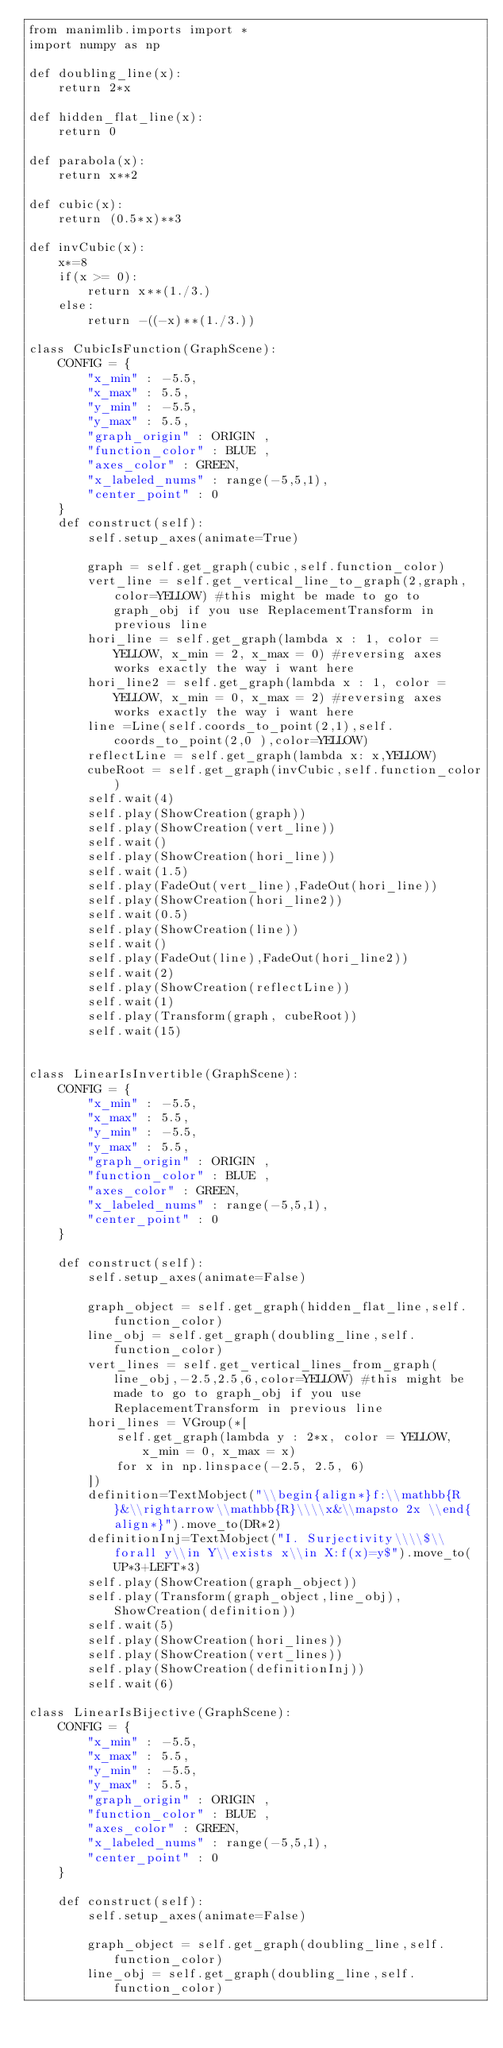<code> <loc_0><loc_0><loc_500><loc_500><_Python_>from manimlib.imports import *
import numpy as np

def doubling_line(x):
    return 2*x

def hidden_flat_line(x):
    return 0

def parabola(x):
    return x**2

def cubic(x):
    return (0.5*x)**3

def invCubic(x):
    x*=8
    if(x >= 0):
        return x**(1./3.)
    else:
        return -((-x)**(1./3.))

class CubicIsFunction(GraphScene):
    CONFIG = {
        "x_min" : -5.5,
        "x_max" : 5.5,
        "y_min" : -5.5,
        "y_max" : 5.5,
        "graph_origin" : ORIGIN ,
        "function_color" : BLUE ,
        "axes_color" : GREEN,
        "x_labeled_nums" : range(-5,5,1),
        "center_point" : 0
    }  
    def construct(self):
        self.setup_axes(animate=True)
        
        graph = self.get_graph(cubic,self.function_color)
        vert_line = self.get_vertical_line_to_graph(2,graph,color=YELLOW) #this might be made to go to graph_obj if you use ReplacementTransform in previous line
        hori_line = self.get_graph(lambda x : 1, color = YELLOW, x_min = 2, x_max = 0) #reversing axes works exactly the way i want here
        hori_line2 = self.get_graph(lambda x : 1, color = YELLOW, x_min = 0, x_max = 2) #reversing axes works exactly the way i want here
        line =Line(self.coords_to_point(2,1),self.coords_to_point(2,0 ),color=YELLOW)
        reflectLine = self.get_graph(lambda x: x,YELLOW)
        cubeRoot = self.get_graph(invCubic,self.function_color)
        self.wait(4)
        self.play(ShowCreation(graph))
        self.play(ShowCreation(vert_line))
        self.wait()
        self.play(ShowCreation(hori_line))
        self.wait(1.5)
        self.play(FadeOut(vert_line),FadeOut(hori_line))
        self.play(ShowCreation(hori_line2))
        self.wait(0.5)
        self.play(ShowCreation(line))
        self.wait()
        self.play(FadeOut(line),FadeOut(hori_line2))
        self.wait(2)
        self.play(ShowCreation(reflectLine))
        self.wait(1)
        self.play(Transform(graph, cubeRoot))
        self.wait(15)


class LinearIsInvertible(GraphScene):
    CONFIG = {
        "x_min" : -5.5,
        "x_max" : 5.5,
        "y_min" : -5.5,
        "y_max" : 5.5,
        "graph_origin" : ORIGIN ,
        "function_color" : BLUE ,
        "axes_color" : GREEN,
        "x_labeled_nums" : range(-5,5,1),
        "center_point" : 0
    }   
    
    def construct(self):
        self.setup_axes(animate=False)
        
        graph_object = self.get_graph(hidden_flat_line,self.function_color)
        line_obj = self.get_graph(doubling_line,self.function_color)
        vert_lines = self.get_vertical_lines_from_graph(line_obj,-2.5,2.5,6,color=YELLOW) #this might be made to go to graph_obj if you use ReplacementTransform in previous line
        hori_lines = VGroup(*[
            self.get_graph(lambda y : 2*x, color = YELLOW, x_min = 0, x_max = x)
            for x in np.linspace(-2.5, 2.5, 6)
        ])
        definition=TextMobject("\\begin{align*}f:\\mathbb{R}&\\rightarrow\\mathbb{R}\\\\x&\\mapsto 2x \\end{align*}").move_to(DR*2)
        definitionInj=TextMobject("I. Surjectivity\\\\$\\forall y\\in Y\\exists x\\in X:f(x)=y$").move_to(UP*3+LEFT*3)
        self.play(ShowCreation(graph_object))
        self.play(Transform(graph_object,line_obj),ShowCreation(definition))
        self.wait(5)
        self.play(ShowCreation(hori_lines))
        self.play(ShowCreation(vert_lines))
        self.play(ShowCreation(definitionInj))
        self.wait(6)

class LinearIsBijective(GraphScene):
    CONFIG = {
        "x_min" : -5.5,
        "x_max" : 5.5,
        "y_min" : -5.5,
        "y_max" : 5.5,
        "graph_origin" : ORIGIN ,
        "function_color" : BLUE ,
        "axes_color" : GREEN,
        "x_labeled_nums" : range(-5,5,1),
        "center_point" : 0
    }   
    
    def construct(self):
        self.setup_axes(animate=False)
        
        graph_object = self.get_graph(doubling_line,self.function_color)
        line_obj = self.get_graph(doubling_line,self.function_color)</code> 